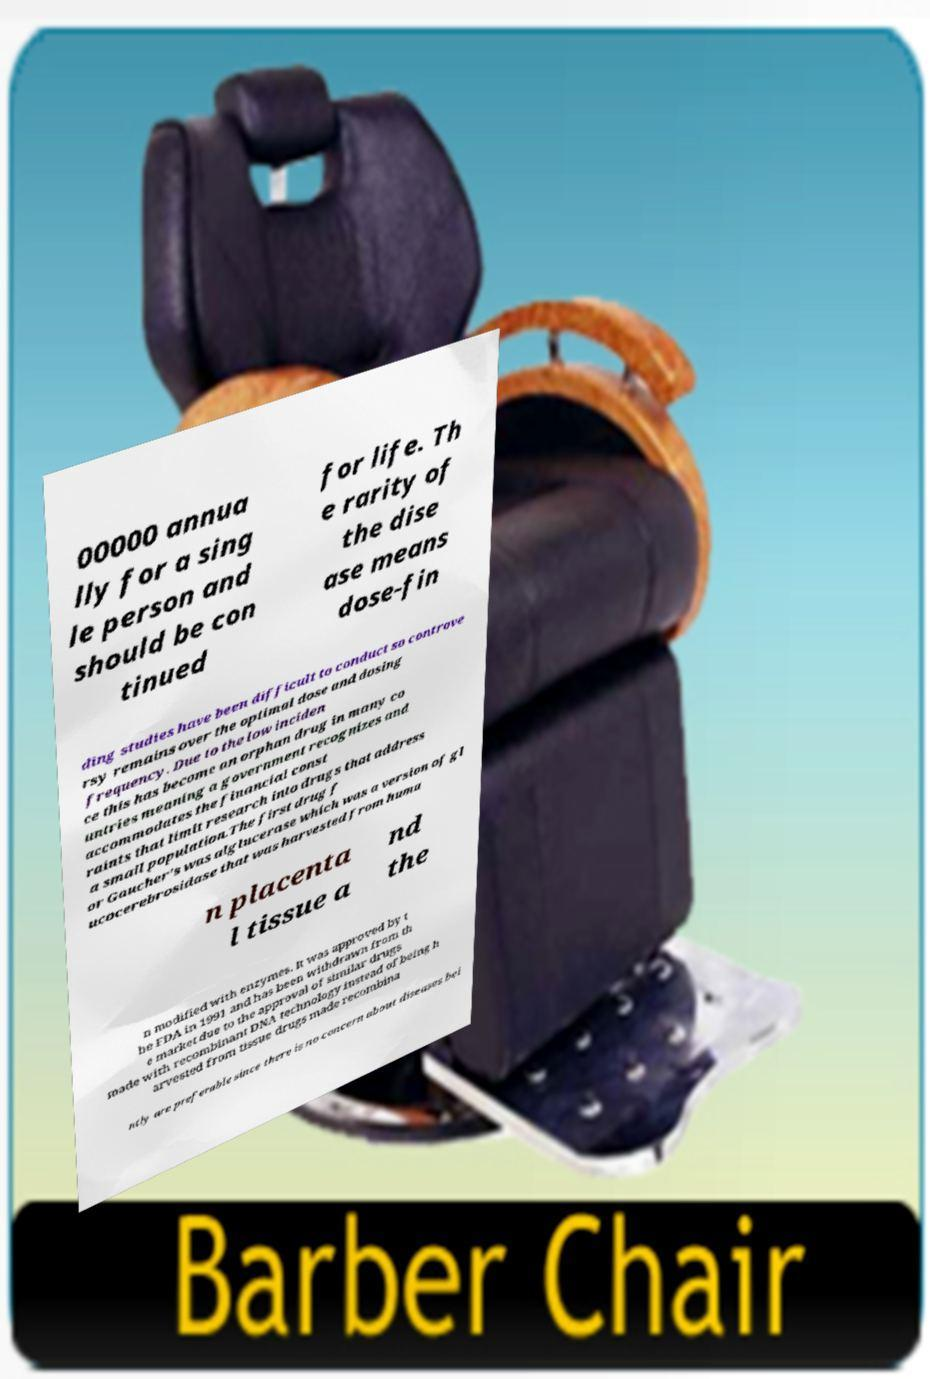What messages or text are displayed in this image? I need them in a readable, typed format. 00000 annua lly for a sing le person and should be con tinued for life. Th e rarity of the dise ase means dose-fin ding studies have been difficult to conduct so controve rsy remains over the optimal dose and dosing frequency. Due to the low inciden ce this has become an orphan drug in many co untries meaning a government recognizes and accommodates the financial const raints that limit research into drugs that address a small population.The first drug f or Gaucher's was alglucerase which was a version of gl ucocerebrosidase that was harvested from huma n placenta l tissue a nd the n modified with enzymes. It was approved by t he FDA in 1991 and has been withdrawn from th e market due to the approval of similar drugs made with recombinant DNA technology instead of being h arvested from tissue drugs made recombina ntly are preferable since there is no concern about diseases bei 